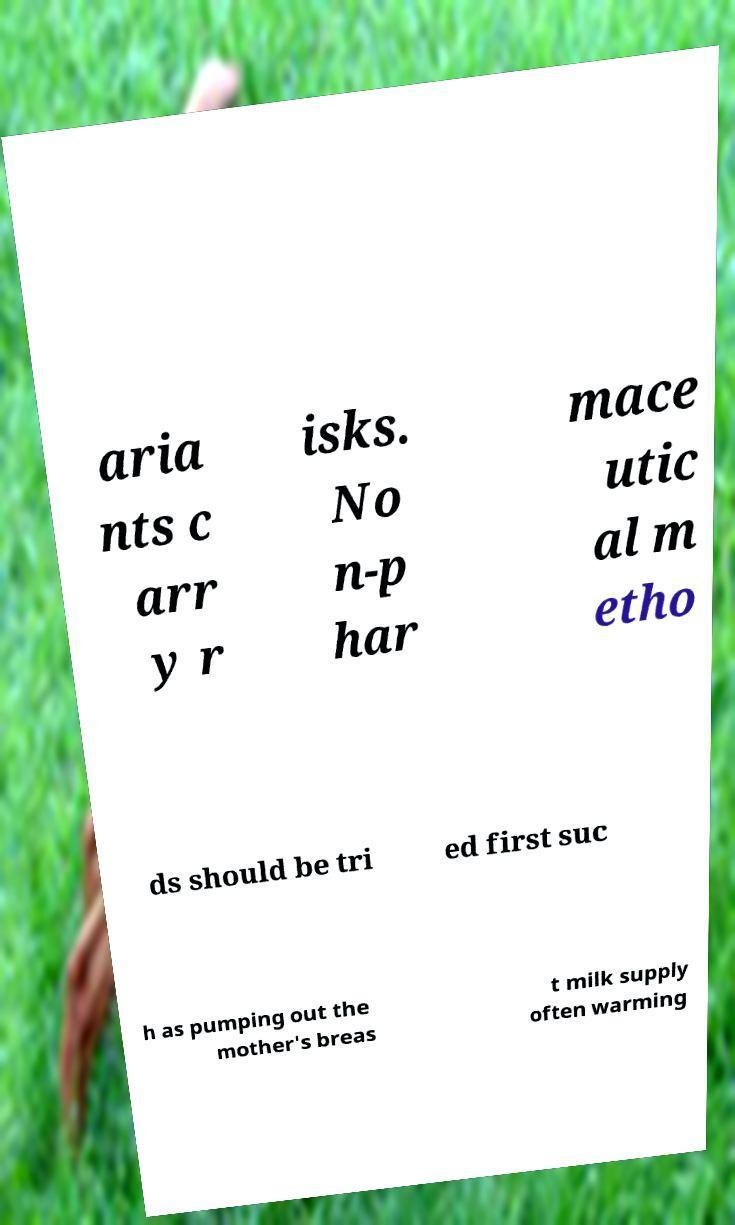Can you accurately transcribe the text from the provided image for me? aria nts c arr y r isks. No n-p har mace utic al m etho ds should be tri ed first suc h as pumping out the mother's breas t milk supply often warming 